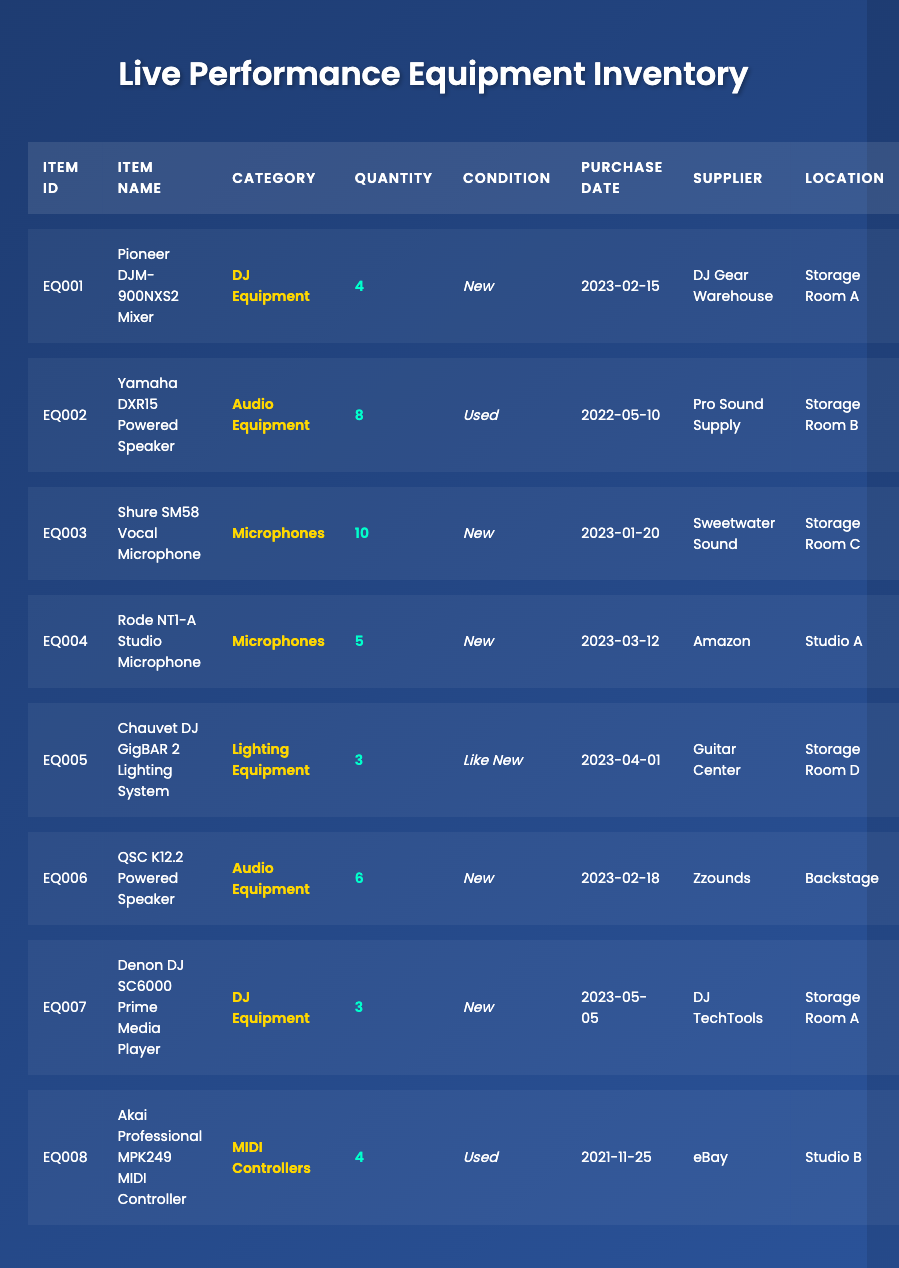What is the total quantity of microphones in the inventory? There are two types of microphones in the inventory: Shure SM58 Vocal Microphone with a quantity of 10 and Rode NT1-A Studio Microphone with a quantity of 5. Adding these together gives 10 + 5 = 15.
Answer: 15 How many pieces of DJ Equipment are available? The inventory has two types of DJ Equipment: Pioneer DJM-900NXS2 Mixer with a quantity of 4 and Denon DJ SC6000 Prime Media Player with a quantity of 3. The total is 4 + 3 = 7.
Answer: 7 Is the Yamaha DXR15 Powered Speaker in new condition? The Yamaha DXR15 Powered Speaker is listed in the inventory as "Used", therefore it is not in new condition.
Answer: No When was the Chauvet DJ GigBAR 2 Lighting System purchased? The purchase date for the Chauvet DJ GigBAR 2 Lighting System is listed in the table as 2023-04-01.
Answer: 2023-04-01 Which item has the highest quantity and what is that quantity? By reviewing the quantity column, the Shure SM58 Vocal Microphone has the highest quantity at 10.
Answer: Shure SM58 Vocal Microphone, 10 Are there more new items than used items in the inventory? There are 5 items in new condition (Pioneer DJM-900NXS2 Mixer, Shure SM58 Vocal Microphone, Rode NT1-A Studio Microphone, QSC K12.2 Powered Speaker, and Denon DJ SC6000 Prime Media Player) and 3 items in used condition (Yamaha DXR15 Powered Speaker and Akai Professional MPK249 MIDI Controller). Since 5 > 3, there are more new items than used items.
Answer: Yes What is the condition of the Akai Professional MPK249 MIDI Controller? The inventory specifies that the condition of the Akai Professional MPK249 MIDI Controller is "Used".
Answer: Used List all items stored in Storage Room A. The items in Storage Room A are: Pioneer DJM-900NXS2 Mixer with a quantity of 4 and Denon DJ SC6000 Prime Media Player with a quantity of 3.
Answer: Pioneer DJM-900NXS2 Mixer, 4; Denon DJ SC6000 Prime Media Player, 3 